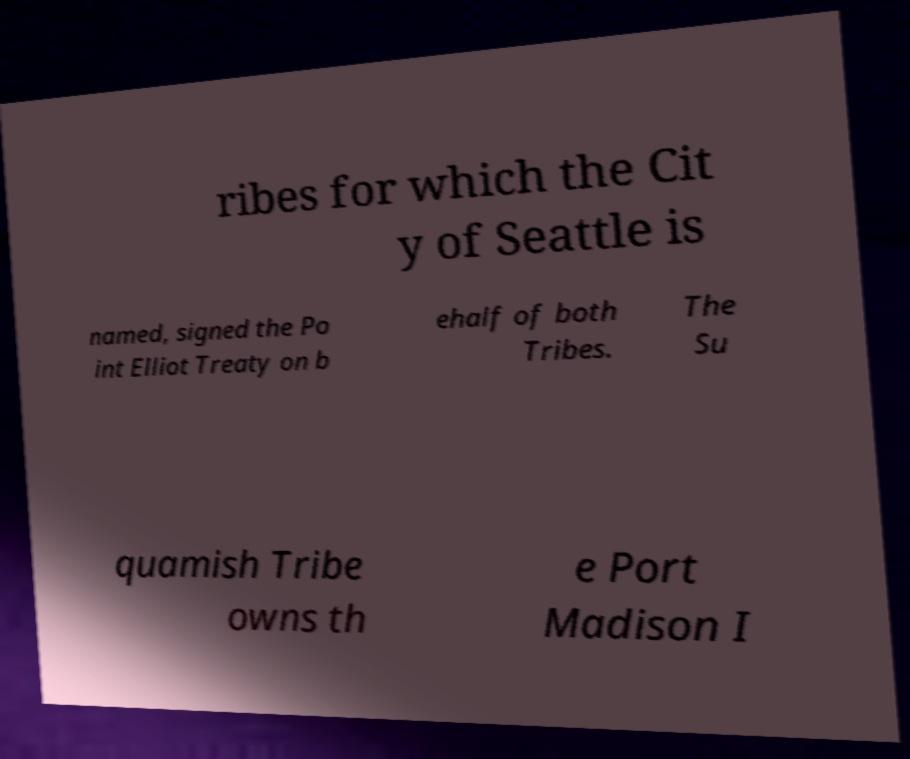Can you accurately transcribe the text from the provided image for me? ribes for which the Cit y of Seattle is named, signed the Po int Elliot Treaty on b ehalf of both Tribes. The Su quamish Tribe owns th e Port Madison I 